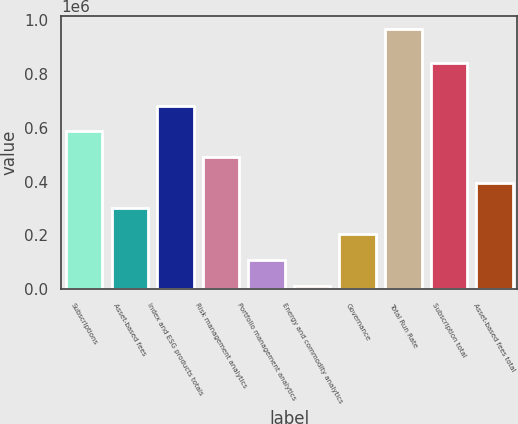Convert chart. <chart><loc_0><loc_0><loc_500><loc_500><bar_chart><fcel>Subscriptions<fcel>Asset-based fees<fcel>Index and ESG products totals<fcel>Risk management analytics<fcel>Portfolio management analytics<fcel>Energy and commodity analytics<fcel>Governance<fcel>Total Run Rate<fcel>Subscription total<fcel>Asset-based fees total<nl><fcel>586978<fcel>300693<fcel>682406<fcel>491549<fcel>109836<fcel>13128<fcel>205264<fcel>967411<fcel>840339<fcel>396121<nl></chart> 